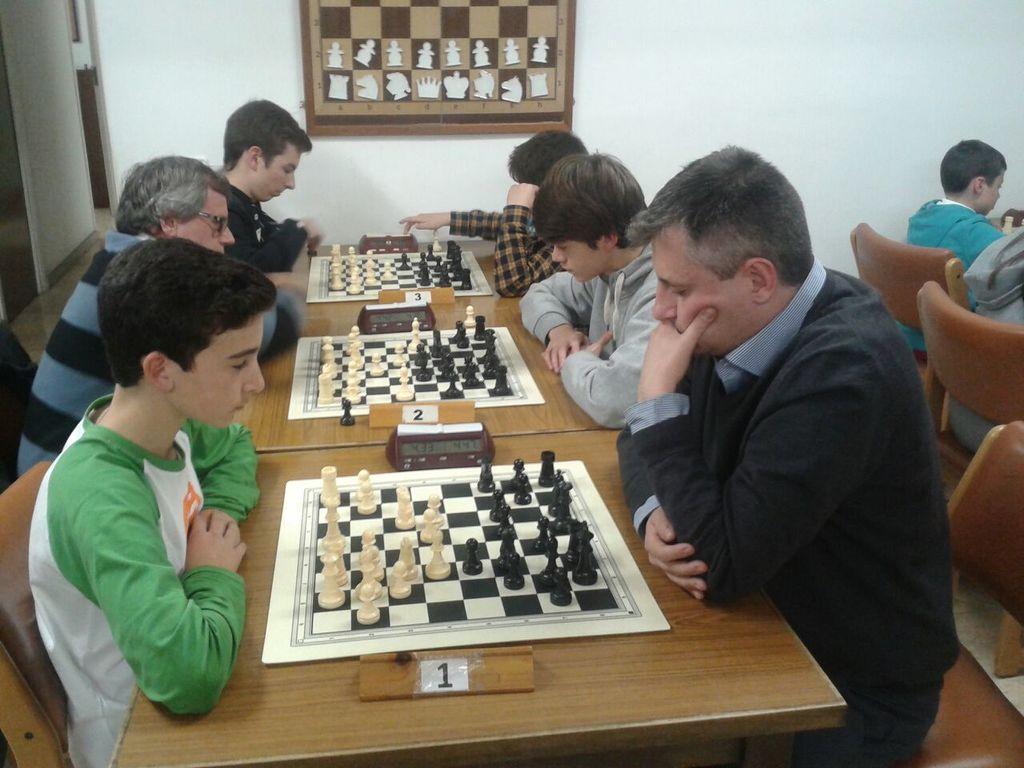Could you give a brief overview of what you see in this image? In this image there are group of people sitting and playing chess game in the table , there is number board , chess board, chess coins, timer and the back ground there is chess frame attached to wall, and a door. 